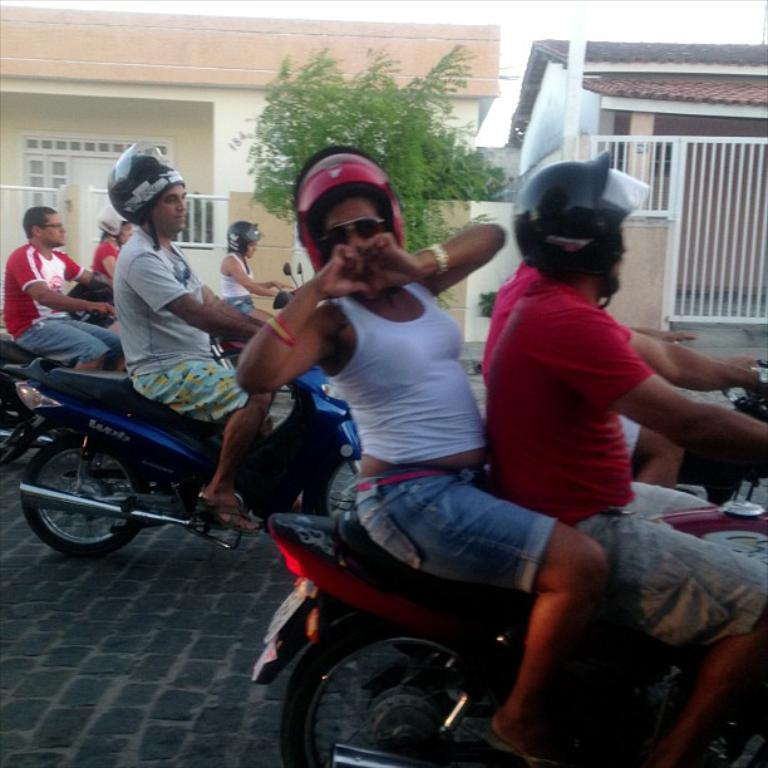How many people are in the image? There are people in the image, but the exact number is not specified. What protective gear are the people wearing? The people are wearing helmets and goggles. What activity are the people engaged in? The people are riding bikes. Where are the bikes located? The bikes are on a road. Can you describe the background of the image? In the background of the image, there are houses, a fence, trees, and a door. Can you see any ghosts in the image? No, there are no ghosts present in the image. Are the people getting a haircut while riding the bikes? No, the people are wearing helmets and goggles, and there is no mention of haircuts in the image. Where is the seashore in the image? There is no mention of a seashore in the image; it features people riding bikes on a road with a background of houses, a fence, trees, and a door. 